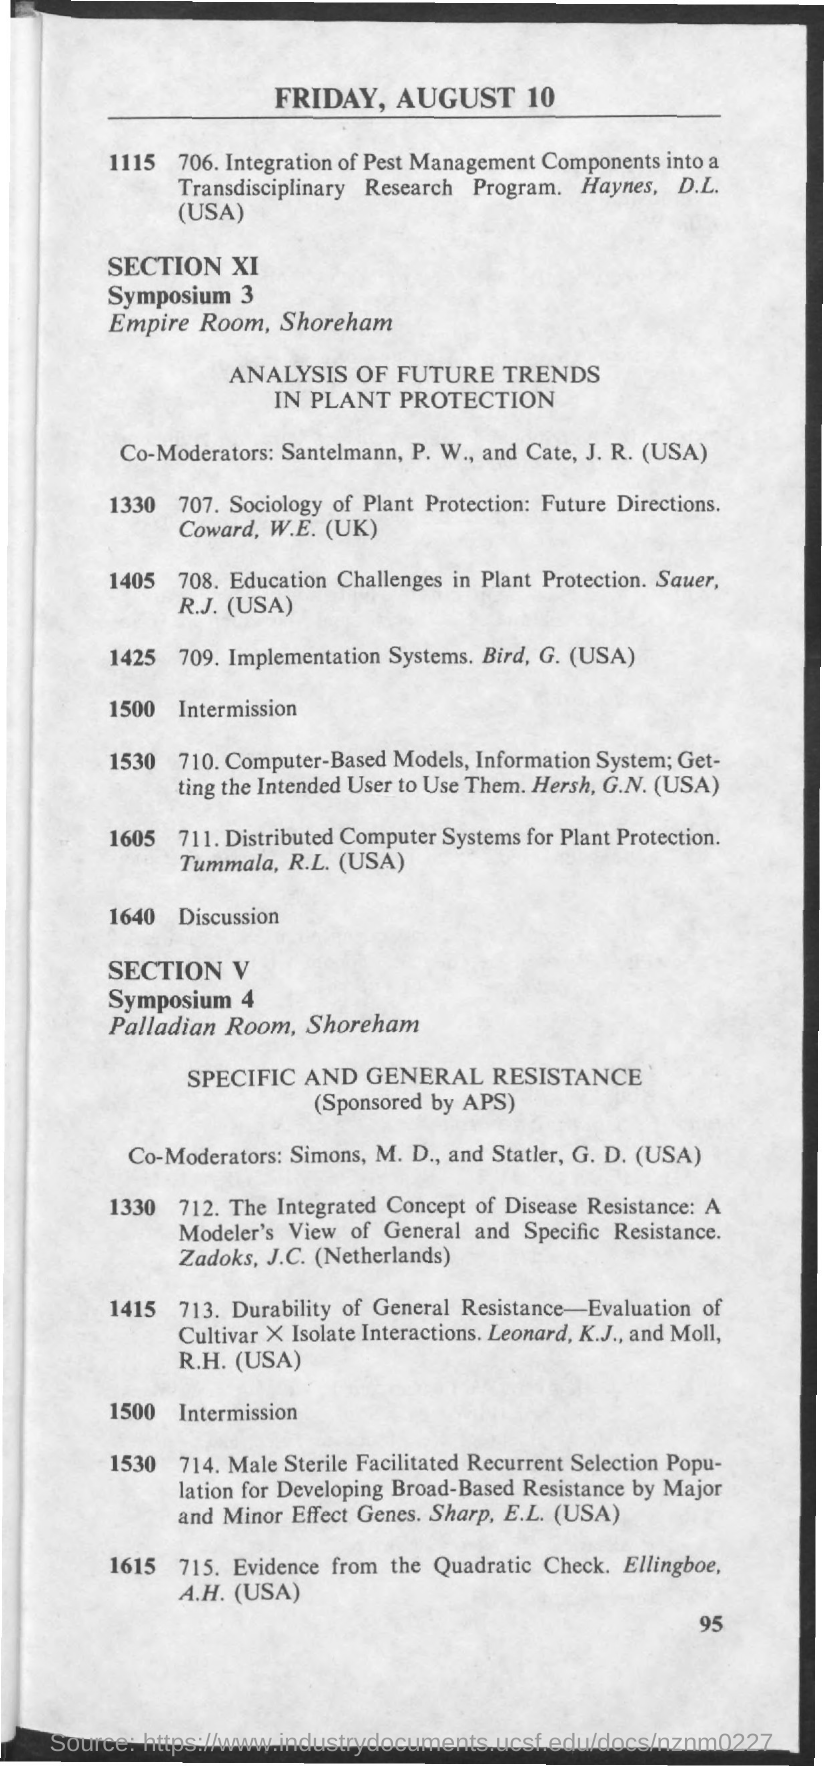What is the date mentioned in the given page ?
Give a very brief answer. Friday , august 10. What is the schedule at the time of 1500 in symposium 3 ?
Make the answer very short. Intermission. What is the schedule at the time of 1500 in symposium 4 ?
Make the answer very short. Intermission. What is the room name mentioned for symposium 3 ?
Keep it short and to the point. Empire room. What is the room name mentioned for symposium 4 ?
Your response must be concise. Palladian Room. 